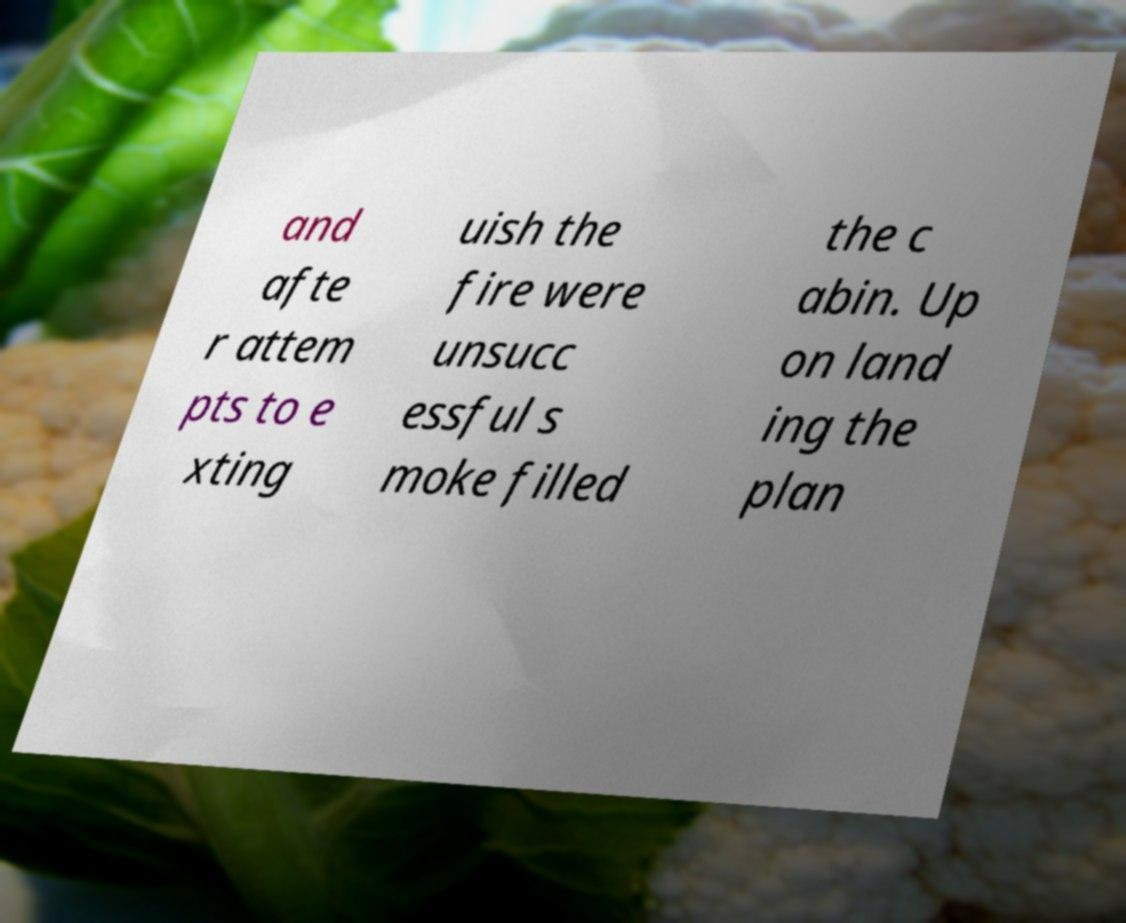For documentation purposes, I need the text within this image transcribed. Could you provide that? and afte r attem pts to e xting uish the fire were unsucc essful s moke filled the c abin. Up on land ing the plan 